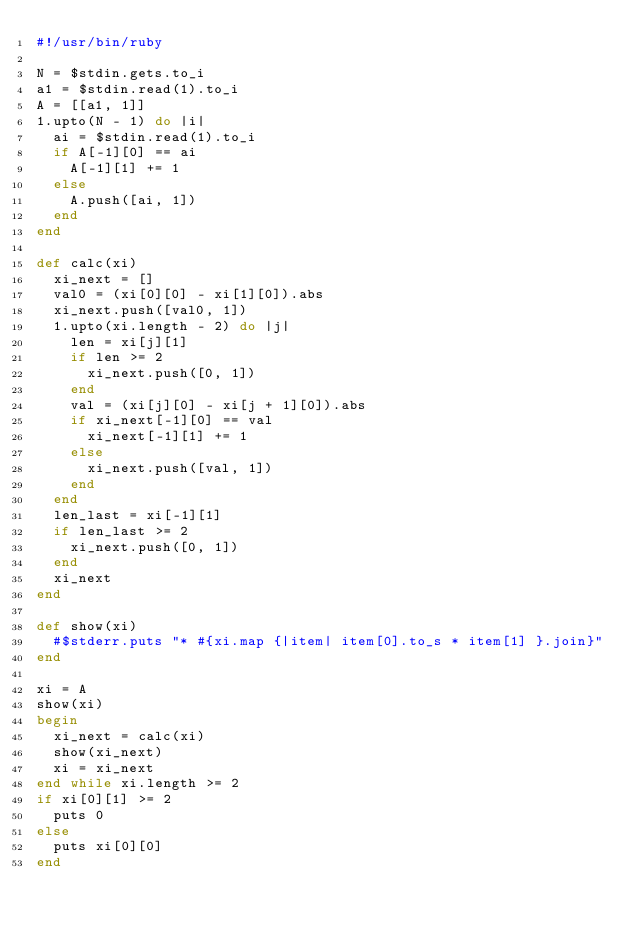Convert code to text. <code><loc_0><loc_0><loc_500><loc_500><_Ruby_>#!/usr/bin/ruby

N = $stdin.gets.to_i
a1 = $stdin.read(1).to_i
A = [[a1, 1]]
1.upto(N - 1) do |i|
  ai = $stdin.read(1).to_i
  if A[-1][0] == ai
    A[-1][1] += 1
  else
    A.push([ai, 1])
  end
end

def calc(xi)
  xi_next = []
  val0 = (xi[0][0] - xi[1][0]).abs
  xi_next.push([val0, 1])
  1.upto(xi.length - 2) do |j|
    len = xi[j][1]
    if len >= 2
      xi_next.push([0, 1])
    end
    val = (xi[j][0] - xi[j + 1][0]).abs
    if xi_next[-1][0] == val
      xi_next[-1][1] += 1
    else
      xi_next.push([val, 1])
    end
  end
  len_last = xi[-1][1]
  if len_last >= 2
    xi_next.push([0, 1])
  end
  xi_next
end

def show(xi)
  #$stderr.puts "* #{xi.map {|item| item[0].to_s * item[1] }.join}"
end

xi = A
show(xi)
begin
  xi_next = calc(xi)
  show(xi_next)
  xi = xi_next
end while xi.length >= 2
if xi[0][1] >= 2
  puts 0
else
  puts xi[0][0]
end
</code> 